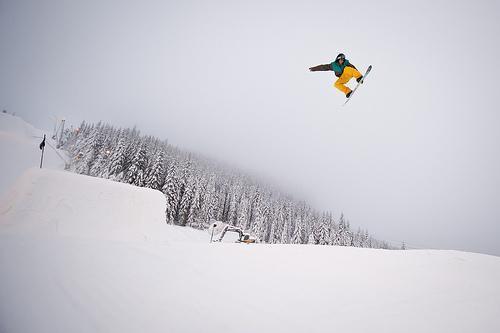How many people are in the picture?
Give a very brief answer. 1. 